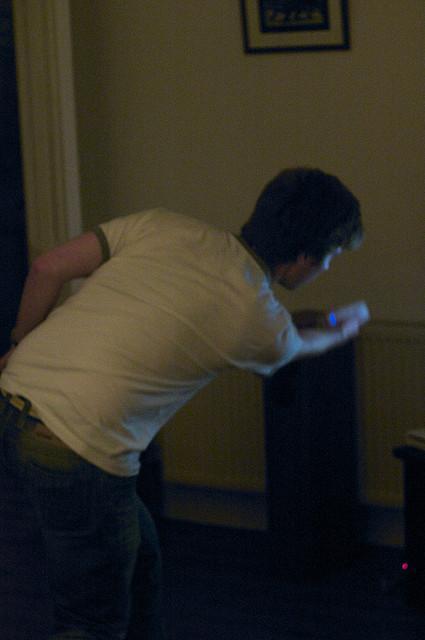How many men are in the picture?
Give a very brief answer. 1. How many benches are there?
Give a very brief answer. 0. 